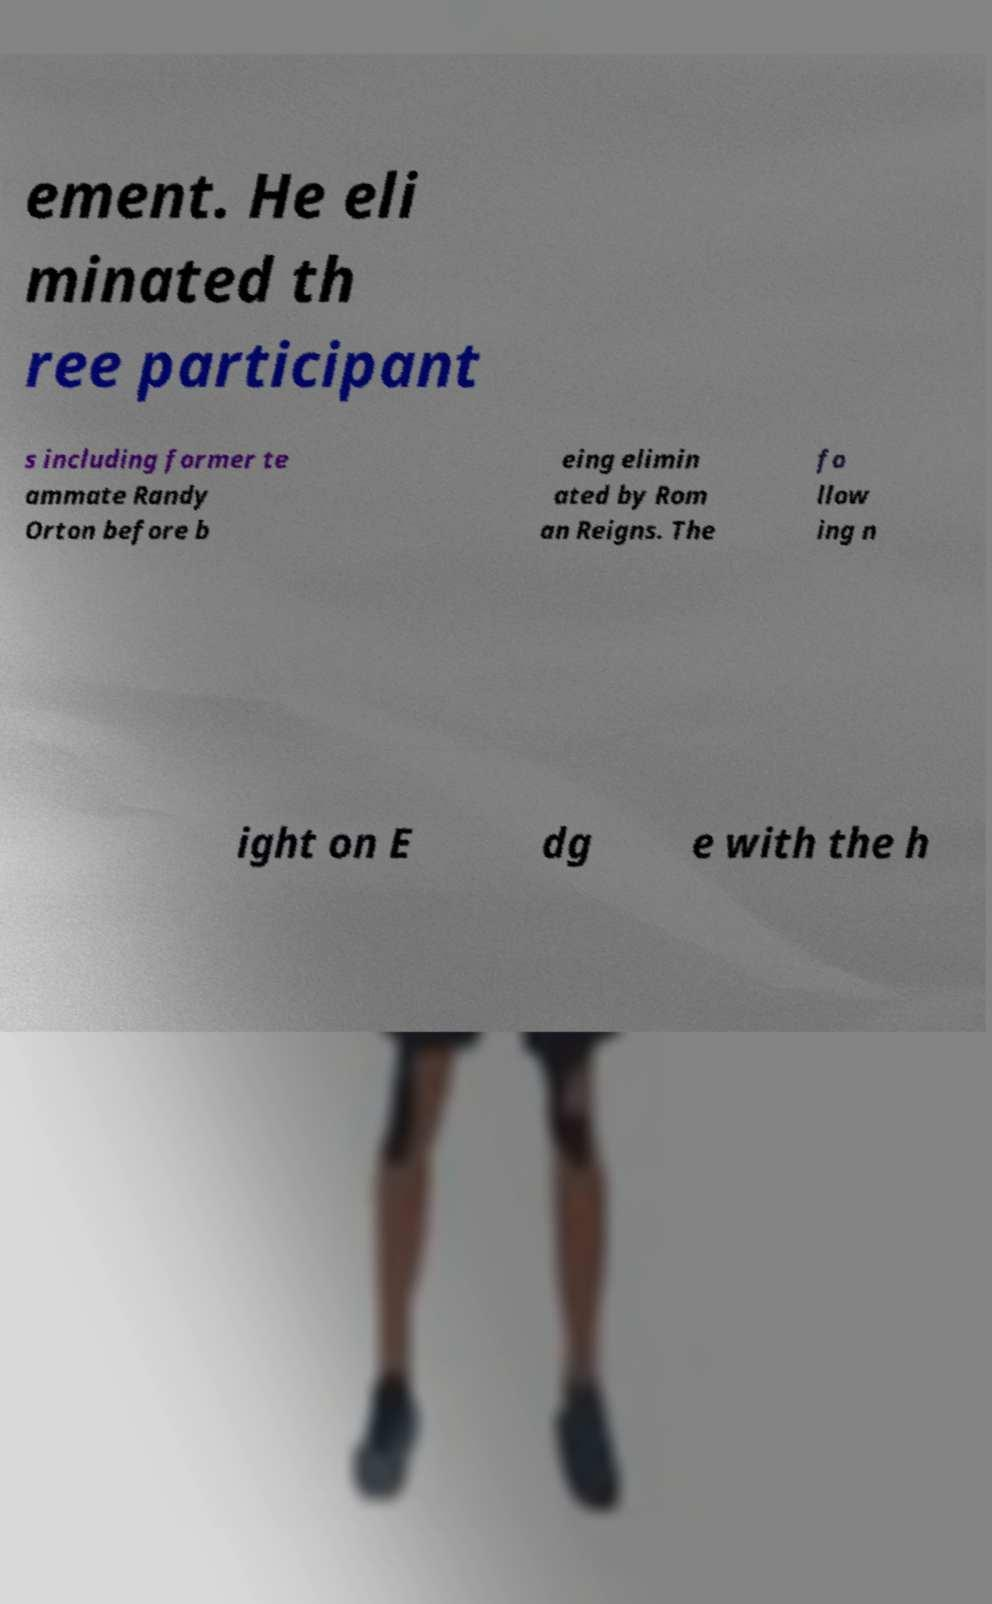Please read and relay the text visible in this image. What does it say? ement. He eli minated th ree participant s including former te ammate Randy Orton before b eing elimin ated by Rom an Reigns. The fo llow ing n ight on E dg e with the h 